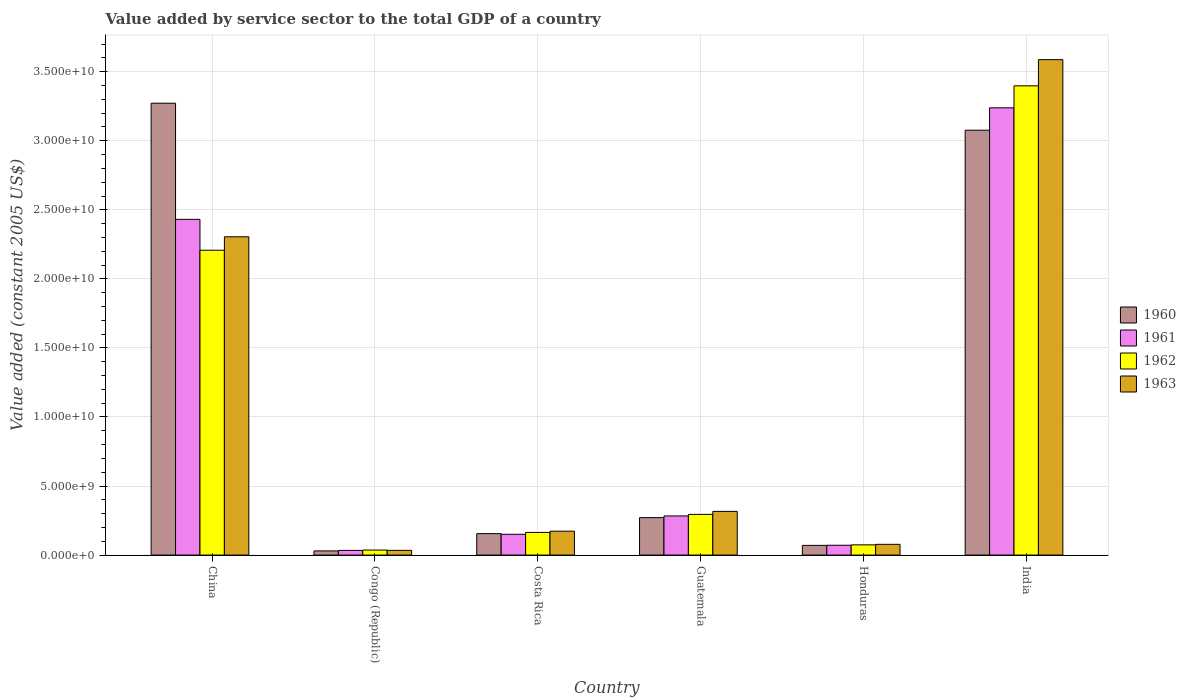How many groups of bars are there?
Your answer should be very brief. 6. Are the number of bars per tick equal to the number of legend labels?
Ensure brevity in your answer.  Yes. Are the number of bars on each tick of the X-axis equal?
Your answer should be very brief. Yes. How many bars are there on the 6th tick from the left?
Your answer should be very brief. 4. What is the label of the 2nd group of bars from the left?
Your answer should be very brief. Congo (Republic). In how many cases, is the number of bars for a given country not equal to the number of legend labels?
Offer a terse response. 0. What is the value added by service sector in 1960 in Congo (Republic)?
Offer a terse response. 3.02e+08. Across all countries, what is the maximum value added by service sector in 1961?
Your response must be concise. 3.24e+1. Across all countries, what is the minimum value added by service sector in 1962?
Provide a short and direct response. 3.64e+08. In which country was the value added by service sector in 1960 maximum?
Give a very brief answer. China. In which country was the value added by service sector in 1961 minimum?
Offer a terse response. Congo (Republic). What is the total value added by service sector in 1963 in the graph?
Keep it short and to the point. 6.49e+1. What is the difference between the value added by service sector in 1960 in China and that in Honduras?
Ensure brevity in your answer.  3.20e+1. What is the difference between the value added by service sector in 1961 in India and the value added by service sector in 1962 in Congo (Republic)?
Your answer should be compact. 3.20e+1. What is the average value added by service sector in 1963 per country?
Provide a short and direct response. 1.08e+1. What is the difference between the value added by service sector of/in 1961 and value added by service sector of/in 1963 in Congo (Republic)?
Your answer should be compact. -3.09e+06. What is the ratio of the value added by service sector in 1960 in China to that in Honduras?
Your answer should be very brief. 46.67. Is the difference between the value added by service sector in 1961 in Congo (Republic) and Guatemala greater than the difference between the value added by service sector in 1963 in Congo (Republic) and Guatemala?
Offer a terse response. Yes. What is the difference between the highest and the second highest value added by service sector in 1962?
Offer a very short reply. -1.91e+1. What is the difference between the highest and the lowest value added by service sector in 1961?
Your answer should be very brief. 3.21e+1. What does the 3rd bar from the left in India represents?
Offer a terse response. 1962. What does the 4th bar from the right in Guatemala represents?
Your answer should be compact. 1960. Are all the bars in the graph horizontal?
Give a very brief answer. No. How many countries are there in the graph?
Provide a succinct answer. 6. Does the graph contain any zero values?
Offer a very short reply. No. Where does the legend appear in the graph?
Your answer should be compact. Center right. How many legend labels are there?
Your answer should be compact. 4. What is the title of the graph?
Ensure brevity in your answer.  Value added by service sector to the total GDP of a country. What is the label or title of the X-axis?
Offer a terse response. Country. What is the label or title of the Y-axis?
Your answer should be compact. Value added (constant 2005 US$). What is the Value added (constant 2005 US$) in 1960 in China?
Your answer should be compact. 3.27e+1. What is the Value added (constant 2005 US$) of 1961 in China?
Ensure brevity in your answer.  2.43e+1. What is the Value added (constant 2005 US$) of 1962 in China?
Give a very brief answer. 2.21e+1. What is the Value added (constant 2005 US$) of 1963 in China?
Your response must be concise. 2.30e+1. What is the Value added (constant 2005 US$) of 1960 in Congo (Republic)?
Your answer should be very brief. 3.02e+08. What is the Value added (constant 2005 US$) in 1961 in Congo (Republic)?
Your answer should be very brief. 3.39e+08. What is the Value added (constant 2005 US$) in 1962 in Congo (Republic)?
Make the answer very short. 3.64e+08. What is the Value added (constant 2005 US$) of 1963 in Congo (Republic)?
Your response must be concise. 3.42e+08. What is the Value added (constant 2005 US$) of 1960 in Costa Rica?
Give a very brief answer. 1.55e+09. What is the Value added (constant 2005 US$) of 1961 in Costa Rica?
Your answer should be compact. 1.51e+09. What is the Value added (constant 2005 US$) in 1962 in Costa Rica?
Offer a terse response. 1.64e+09. What is the Value added (constant 2005 US$) in 1963 in Costa Rica?
Ensure brevity in your answer.  1.73e+09. What is the Value added (constant 2005 US$) of 1960 in Guatemala?
Ensure brevity in your answer.  2.71e+09. What is the Value added (constant 2005 US$) in 1961 in Guatemala?
Offer a very short reply. 2.83e+09. What is the Value added (constant 2005 US$) of 1962 in Guatemala?
Offer a terse response. 2.95e+09. What is the Value added (constant 2005 US$) in 1963 in Guatemala?
Your response must be concise. 3.16e+09. What is the Value added (constant 2005 US$) in 1960 in Honduras?
Keep it short and to the point. 7.01e+08. What is the Value added (constant 2005 US$) in 1961 in Honduras?
Make the answer very short. 7.12e+08. What is the Value added (constant 2005 US$) of 1962 in Honduras?
Offer a very short reply. 7.41e+08. What is the Value added (constant 2005 US$) in 1963 in Honduras?
Provide a succinct answer. 7.78e+08. What is the Value added (constant 2005 US$) of 1960 in India?
Give a very brief answer. 3.08e+1. What is the Value added (constant 2005 US$) of 1961 in India?
Ensure brevity in your answer.  3.24e+1. What is the Value added (constant 2005 US$) of 1962 in India?
Provide a succinct answer. 3.40e+1. What is the Value added (constant 2005 US$) in 1963 in India?
Give a very brief answer. 3.59e+1. Across all countries, what is the maximum Value added (constant 2005 US$) in 1960?
Provide a short and direct response. 3.27e+1. Across all countries, what is the maximum Value added (constant 2005 US$) of 1961?
Ensure brevity in your answer.  3.24e+1. Across all countries, what is the maximum Value added (constant 2005 US$) of 1962?
Make the answer very short. 3.40e+1. Across all countries, what is the maximum Value added (constant 2005 US$) in 1963?
Your response must be concise. 3.59e+1. Across all countries, what is the minimum Value added (constant 2005 US$) of 1960?
Provide a succinct answer. 3.02e+08. Across all countries, what is the minimum Value added (constant 2005 US$) of 1961?
Offer a very short reply. 3.39e+08. Across all countries, what is the minimum Value added (constant 2005 US$) in 1962?
Give a very brief answer. 3.64e+08. Across all countries, what is the minimum Value added (constant 2005 US$) in 1963?
Ensure brevity in your answer.  3.42e+08. What is the total Value added (constant 2005 US$) of 1960 in the graph?
Offer a very short reply. 6.88e+1. What is the total Value added (constant 2005 US$) in 1961 in the graph?
Keep it short and to the point. 6.21e+1. What is the total Value added (constant 2005 US$) of 1962 in the graph?
Your response must be concise. 6.18e+1. What is the total Value added (constant 2005 US$) in 1963 in the graph?
Give a very brief answer. 6.49e+1. What is the difference between the Value added (constant 2005 US$) in 1960 in China and that in Congo (Republic)?
Ensure brevity in your answer.  3.24e+1. What is the difference between the Value added (constant 2005 US$) of 1961 in China and that in Congo (Republic)?
Ensure brevity in your answer.  2.40e+1. What is the difference between the Value added (constant 2005 US$) in 1962 in China and that in Congo (Republic)?
Give a very brief answer. 2.17e+1. What is the difference between the Value added (constant 2005 US$) of 1963 in China and that in Congo (Republic)?
Offer a terse response. 2.27e+1. What is the difference between the Value added (constant 2005 US$) of 1960 in China and that in Costa Rica?
Your response must be concise. 3.12e+1. What is the difference between the Value added (constant 2005 US$) of 1961 in China and that in Costa Rica?
Your response must be concise. 2.28e+1. What is the difference between the Value added (constant 2005 US$) in 1962 in China and that in Costa Rica?
Give a very brief answer. 2.04e+1. What is the difference between the Value added (constant 2005 US$) in 1963 in China and that in Costa Rica?
Give a very brief answer. 2.13e+1. What is the difference between the Value added (constant 2005 US$) of 1960 in China and that in Guatemala?
Make the answer very short. 3.00e+1. What is the difference between the Value added (constant 2005 US$) of 1961 in China and that in Guatemala?
Your answer should be very brief. 2.15e+1. What is the difference between the Value added (constant 2005 US$) in 1962 in China and that in Guatemala?
Your response must be concise. 1.91e+1. What is the difference between the Value added (constant 2005 US$) in 1963 in China and that in Guatemala?
Your answer should be compact. 1.99e+1. What is the difference between the Value added (constant 2005 US$) of 1960 in China and that in Honduras?
Your response must be concise. 3.20e+1. What is the difference between the Value added (constant 2005 US$) of 1961 in China and that in Honduras?
Your answer should be compact. 2.36e+1. What is the difference between the Value added (constant 2005 US$) of 1962 in China and that in Honduras?
Give a very brief answer. 2.13e+1. What is the difference between the Value added (constant 2005 US$) of 1963 in China and that in Honduras?
Your answer should be very brief. 2.23e+1. What is the difference between the Value added (constant 2005 US$) in 1960 in China and that in India?
Make the answer very short. 1.95e+09. What is the difference between the Value added (constant 2005 US$) in 1961 in China and that in India?
Provide a short and direct response. -8.08e+09. What is the difference between the Value added (constant 2005 US$) of 1962 in China and that in India?
Keep it short and to the point. -1.19e+1. What is the difference between the Value added (constant 2005 US$) in 1963 in China and that in India?
Provide a short and direct response. -1.28e+1. What is the difference between the Value added (constant 2005 US$) in 1960 in Congo (Republic) and that in Costa Rica?
Keep it short and to the point. -1.25e+09. What is the difference between the Value added (constant 2005 US$) of 1961 in Congo (Republic) and that in Costa Rica?
Offer a terse response. -1.17e+09. What is the difference between the Value added (constant 2005 US$) in 1962 in Congo (Republic) and that in Costa Rica?
Provide a succinct answer. -1.28e+09. What is the difference between the Value added (constant 2005 US$) in 1963 in Congo (Republic) and that in Costa Rica?
Your response must be concise. -1.39e+09. What is the difference between the Value added (constant 2005 US$) of 1960 in Congo (Republic) and that in Guatemala?
Give a very brief answer. -2.41e+09. What is the difference between the Value added (constant 2005 US$) of 1961 in Congo (Republic) and that in Guatemala?
Keep it short and to the point. -2.49e+09. What is the difference between the Value added (constant 2005 US$) of 1962 in Congo (Republic) and that in Guatemala?
Provide a short and direct response. -2.58e+09. What is the difference between the Value added (constant 2005 US$) of 1963 in Congo (Republic) and that in Guatemala?
Your answer should be compact. -2.82e+09. What is the difference between the Value added (constant 2005 US$) in 1960 in Congo (Republic) and that in Honduras?
Keep it short and to the point. -4.00e+08. What is the difference between the Value added (constant 2005 US$) of 1961 in Congo (Republic) and that in Honduras?
Provide a short and direct response. -3.73e+08. What is the difference between the Value added (constant 2005 US$) of 1962 in Congo (Republic) and that in Honduras?
Offer a terse response. -3.77e+08. What is the difference between the Value added (constant 2005 US$) in 1963 in Congo (Republic) and that in Honduras?
Offer a very short reply. -4.36e+08. What is the difference between the Value added (constant 2005 US$) in 1960 in Congo (Republic) and that in India?
Offer a terse response. -3.05e+1. What is the difference between the Value added (constant 2005 US$) in 1961 in Congo (Republic) and that in India?
Make the answer very short. -3.21e+1. What is the difference between the Value added (constant 2005 US$) of 1962 in Congo (Republic) and that in India?
Offer a very short reply. -3.36e+1. What is the difference between the Value added (constant 2005 US$) of 1963 in Congo (Republic) and that in India?
Offer a very short reply. -3.55e+1. What is the difference between the Value added (constant 2005 US$) of 1960 in Costa Rica and that in Guatemala?
Offer a very short reply. -1.16e+09. What is the difference between the Value added (constant 2005 US$) of 1961 in Costa Rica and that in Guatemala?
Your answer should be compact. -1.33e+09. What is the difference between the Value added (constant 2005 US$) in 1962 in Costa Rica and that in Guatemala?
Your answer should be very brief. -1.31e+09. What is the difference between the Value added (constant 2005 US$) of 1963 in Costa Rica and that in Guatemala?
Your response must be concise. -1.43e+09. What is the difference between the Value added (constant 2005 US$) of 1960 in Costa Rica and that in Honduras?
Your response must be concise. 8.51e+08. What is the difference between the Value added (constant 2005 US$) of 1961 in Costa Rica and that in Honduras?
Ensure brevity in your answer.  7.94e+08. What is the difference between the Value added (constant 2005 US$) of 1962 in Costa Rica and that in Honduras?
Ensure brevity in your answer.  9.01e+08. What is the difference between the Value added (constant 2005 US$) of 1963 in Costa Rica and that in Honduras?
Make the answer very short. 9.53e+08. What is the difference between the Value added (constant 2005 US$) in 1960 in Costa Rica and that in India?
Your answer should be compact. -2.92e+1. What is the difference between the Value added (constant 2005 US$) of 1961 in Costa Rica and that in India?
Ensure brevity in your answer.  -3.09e+1. What is the difference between the Value added (constant 2005 US$) in 1962 in Costa Rica and that in India?
Give a very brief answer. -3.23e+1. What is the difference between the Value added (constant 2005 US$) of 1963 in Costa Rica and that in India?
Offer a terse response. -3.41e+1. What is the difference between the Value added (constant 2005 US$) of 1960 in Guatemala and that in Honduras?
Offer a terse response. 2.01e+09. What is the difference between the Value added (constant 2005 US$) in 1961 in Guatemala and that in Honduras?
Make the answer very short. 2.12e+09. What is the difference between the Value added (constant 2005 US$) of 1962 in Guatemala and that in Honduras?
Your answer should be compact. 2.21e+09. What is the difference between the Value added (constant 2005 US$) of 1963 in Guatemala and that in Honduras?
Offer a terse response. 2.39e+09. What is the difference between the Value added (constant 2005 US$) in 1960 in Guatemala and that in India?
Your answer should be compact. -2.81e+1. What is the difference between the Value added (constant 2005 US$) of 1961 in Guatemala and that in India?
Offer a very short reply. -2.96e+1. What is the difference between the Value added (constant 2005 US$) in 1962 in Guatemala and that in India?
Offer a terse response. -3.10e+1. What is the difference between the Value added (constant 2005 US$) of 1963 in Guatemala and that in India?
Make the answer very short. -3.27e+1. What is the difference between the Value added (constant 2005 US$) of 1960 in Honduras and that in India?
Offer a terse response. -3.01e+1. What is the difference between the Value added (constant 2005 US$) in 1961 in Honduras and that in India?
Your response must be concise. -3.17e+1. What is the difference between the Value added (constant 2005 US$) of 1962 in Honduras and that in India?
Ensure brevity in your answer.  -3.32e+1. What is the difference between the Value added (constant 2005 US$) of 1963 in Honduras and that in India?
Provide a succinct answer. -3.51e+1. What is the difference between the Value added (constant 2005 US$) of 1960 in China and the Value added (constant 2005 US$) of 1961 in Congo (Republic)?
Give a very brief answer. 3.24e+1. What is the difference between the Value added (constant 2005 US$) in 1960 in China and the Value added (constant 2005 US$) in 1962 in Congo (Republic)?
Provide a short and direct response. 3.24e+1. What is the difference between the Value added (constant 2005 US$) in 1960 in China and the Value added (constant 2005 US$) in 1963 in Congo (Republic)?
Ensure brevity in your answer.  3.24e+1. What is the difference between the Value added (constant 2005 US$) of 1961 in China and the Value added (constant 2005 US$) of 1962 in Congo (Republic)?
Make the answer very short. 2.39e+1. What is the difference between the Value added (constant 2005 US$) of 1961 in China and the Value added (constant 2005 US$) of 1963 in Congo (Republic)?
Make the answer very short. 2.40e+1. What is the difference between the Value added (constant 2005 US$) in 1962 in China and the Value added (constant 2005 US$) in 1963 in Congo (Republic)?
Provide a short and direct response. 2.17e+1. What is the difference between the Value added (constant 2005 US$) in 1960 in China and the Value added (constant 2005 US$) in 1961 in Costa Rica?
Ensure brevity in your answer.  3.12e+1. What is the difference between the Value added (constant 2005 US$) in 1960 in China and the Value added (constant 2005 US$) in 1962 in Costa Rica?
Your answer should be compact. 3.11e+1. What is the difference between the Value added (constant 2005 US$) in 1960 in China and the Value added (constant 2005 US$) in 1963 in Costa Rica?
Your response must be concise. 3.10e+1. What is the difference between the Value added (constant 2005 US$) in 1961 in China and the Value added (constant 2005 US$) in 1962 in Costa Rica?
Your response must be concise. 2.27e+1. What is the difference between the Value added (constant 2005 US$) in 1961 in China and the Value added (constant 2005 US$) in 1963 in Costa Rica?
Give a very brief answer. 2.26e+1. What is the difference between the Value added (constant 2005 US$) in 1962 in China and the Value added (constant 2005 US$) in 1963 in Costa Rica?
Keep it short and to the point. 2.03e+1. What is the difference between the Value added (constant 2005 US$) of 1960 in China and the Value added (constant 2005 US$) of 1961 in Guatemala?
Your answer should be compact. 2.99e+1. What is the difference between the Value added (constant 2005 US$) in 1960 in China and the Value added (constant 2005 US$) in 1962 in Guatemala?
Provide a succinct answer. 2.98e+1. What is the difference between the Value added (constant 2005 US$) in 1960 in China and the Value added (constant 2005 US$) in 1963 in Guatemala?
Provide a succinct answer. 2.96e+1. What is the difference between the Value added (constant 2005 US$) in 1961 in China and the Value added (constant 2005 US$) in 1962 in Guatemala?
Ensure brevity in your answer.  2.14e+1. What is the difference between the Value added (constant 2005 US$) in 1961 in China and the Value added (constant 2005 US$) in 1963 in Guatemala?
Give a very brief answer. 2.11e+1. What is the difference between the Value added (constant 2005 US$) of 1962 in China and the Value added (constant 2005 US$) of 1963 in Guatemala?
Keep it short and to the point. 1.89e+1. What is the difference between the Value added (constant 2005 US$) of 1960 in China and the Value added (constant 2005 US$) of 1961 in Honduras?
Keep it short and to the point. 3.20e+1. What is the difference between the Value added (constant 2005 US$) of 1960 in China and the Value added (constant 2005 US$) of 1962 in Honduras?
Ensure brevity in your answer.  3.20e+1. What is the difference between the Value added (constant 2005 US$) in 1960 in China and the Value added (constant 2005 US$) in 1963 in Honduras?
Your answer should be very brief. 3.19e+1. What is the difference between the Value added (constant 2005 US$) of 1961 in China and the Value added (constant 2005 US$) of 1962 in Honduras?
Offer a very short reply. 2.36e+1. What is the difference between the Value added (constant 2005 US$) in 1961 in China and the Value added (constant 2005 US$) in 1963 in Honduras?
Make the answer very short. 2.35e+1. What is the difference between the Value added (constant 2005 US$) in 1962 in China and the Value added (constant 2005 US$) in 1963 in Honduras?
Make the answer very short. 2.13e+1. What is the difference between the Value added (constant 2005 US$) in 1960 in China and the Value added (constant 2005 US$) in 1961 in India?
Your answer should be compact. 3.34e+08. What is the difference between the Value added (constant 2005 US$) of 1960 in China and the Value added (constant 2005 US$) of 1962 in India?
Offer a very short reply. -1.26e+09. What is the difference between the Value added (constant 2005 US$) of 1960 in China and the Value added (constant 2005 US$) of 1963 in India?
Provide a short and direct response. -3.15e+09. What is the difference between the Value added (constant 2005 US$) of 1961 in China and the Value added (constant 2005 US$) of 1962 in India?
Provide a succinct answer. -9.67e+09. What is the difference between the Value added (constant 2005 US$) of 1961 in China and the Value added (constant 2005 US$) of 1963 in India?
Your response must be concise. -1.16e+1. What is the difference between the Value added (constant 2005 US$) of 1962 in China and the Value added (constant 2005 US$) of 1963 in India?
Make the answer very short. -1.38e+1. What is the difference between the Value added (constant 2005 US$) of 1960 in Congo (Republic) and the Value added (constant 2005 US$) of 1961 in Costa Rica?
Ensure brevity in your answer.  -1.20e+09. What is the difference between the Value added (constant 2005 US$) in 1960 in Congo (Republic) and the Value added (constant 2005 US$) in 1962 in Costa Rica?
Make the answer very short. -1.34e+09. What is the difference between the Value added (constant 2005 US$) in 1960 in Congo (Republic) and the Value added (constant 2005 US$) in 1963 in Costa Rica?
Your response must be concise. -1.43e+09. What is the difference between the Value added (constant 2005 US$) in 1961 in Congo (Republic) and the Value added (constant 2005 US$) in 1962 in Costa Rica?
Provide a succinct answer. -1.30e+09. What is the difference between the Value added (constant 2005 US$) in 1961 in Congo (Republic) and the Value added (constant 2005 US$) in 1963 in Costa Rica?
Offer a very short reply. -1.39e+09. What is the difference between the Value added (constant 2005 US$) in 1962 in Congo (Republic) and the Value added (constant 2005 US$) in 1963 in Costa Rica?
Give a very brief answer. -1.37e+09. What is the difference between the Value added (constant 2005 US$) of 1960 in Congo (Republic) and the Value added (constant 2005 US$) of 1961 in Guatemala?
Offer a very short reply. -2.53e+09. What is the difference between the Value added (constant 2005 US$) of 1960 in Congo (Republic) and the Value added (constant 2005 US$) of 1962 in Guatemala?
Offer a terse response. -2.65e+09. What is the difference between the Value added (constant 2005 US$) in 1960 in Congo (Republic) and the Value added (constant 2005 US$) in 1963 in Guatemala?
Your answer should be compact. -2.86e+09. What is the difference between the Value added (constant 2005 US$) of 1961 in Congo (Republic) and the Value added (constant 2005 US$) of 1962 in Guatemala?
Your answer should be very brief. -2.61e+09. What is the difference between the Value added (constant 2005 US$) in 1961 in Congo (Republic) and the Value added (constant 2005 US$) in 1963 in Guatemala?
Provide a short and direct response. -2.83e+09. What is the difference between the Value added (constant 2005 US$) of 1962 in Congo (Republic) and the Value added (constant 2005 US$) of 1963 in Guatemala?
Your response must be concise. -2.80e+09. What is the difference between the Value added (constant 2005 US$) in 1960 in Congo (Republic) and the Value added (constant 2005 US$) in 1961 in Honduras?
Your answer should be compact. -4.10e+08. What is the difference between the Value added (constant 2005 US$) of 1960 in Congo (Republic) and the Value added (constant 2005 US$) of 1962 in Honduras?
Offer a terse response. -4.39e+08. What is the difference between the Value added (constant 2005 US$) in 1960 in Congo (Republic) and the Value added (constant 2005 US$) in 1963 in Honduras?
Provide a succinct answer. -4.76e+08. What is the difference between the Value added (constant 2005 US$) in 1961 in Congo (Republic) and the Value added (constant 2005 US$) in 1962 in Honduras?
Your answer should be very brief. -4.02e+08. What is the difference between the Value added (constant 2005 US$) in 1961 in Congo (Republic) and the Value added (constant 2005 US$) in 1963 in Honduras?
Keep it short and to the point. -4.39e+08. What is the difference between the Value added (constant 2005 US$) of 1962 in Congo (Republic) and the Value added (constant 2005 US$) of 1963 in Honduras?
Your response must be concise. -4.14e+08. What is the difference between the Value added (constant 2005 US$) in 1960 in Congo (Republic) and the Value added (constant 2005 US$) in 1961 in India?
Offer a terse response. -3.21e+1. What is the difference between the Value added (constant 2005 US$) in 1960 in Congo (Republic) and the Value added (constant 2005 US$) in 1962 in India?
Your answer should be compact. -3.37e+1. What is the difference between the Value added (constant 2005 US$) of 1960 in Congo (Republic) and the Value added (constant 2005 US$) of 1963 in India?
Provide a succinct answer. -3.56e+1. What is the difference between the Value added (constant 2005 US$) of 1961 in Congo (Republic) and the Value added (constant 2005 US$) of 1962 in India?
Provide a succinct answer. -3.36e+1. What is the difference between the Value added (constant 2005 US$) in 1961 in Congo (Republic) and the Value added (constant 2005 US$) in 1963 in India?
Make the answer very short. -3.55e+1. What is the difference between the Value added (constant 2005 US$) in 1962 in Congo (Republic) and the Value added (constant 2005 US$) in 1963 in India?
Your response must be concise. -3.55e+1. What is the difference between the Value added (constant 2005 US$) in 1960 in Costa Rica and the Value added (constant 2005 US$) in 1961 in Guatemala?
Make the answer very short. -1.28e+09. What is the difference between the Value added (constant 2005 US$) of 1960 in Costa Rica and the Value added (constant 2005 US$) of 1962 in Guatemala?
Ensure brevity in your answer.  -1.39e+09. What is the difference between the Value added (constant 2005 US$) of 1960 in Costa Rica and the Value added (constant 2005 US$) of 1963 in Guatemala?
Provide a short and direct response. -1.61e+09. What is the difference between the Value added (constant 2005 US$) in 1961 in Costa Rica and the Value added (constant 2005 US$) in 1962 in Guatemala?
Your answer should be compact. -1.44e+09. What is the difference between the Value added (constant 2005 US$) in 1961 in Costa Rica and the Value added (constant 2005 US$) in 1963 in Guatemala?
Provide a succinct answer. -1.66e+09. What is the difference between the Value added (constant 2005 US$) in 1962 in Costa Rica and the Value added (constant 2005 US$) in 1963 in Guatemala?
Ensure brevity in your answer.  -1.52e+09. What is the difference between the Value added (constant 2005 US$) of 1960 in Costa Rica and the Value added (constant 2005 US$) of 1961 in Honduras?
Offer a terse response. 8.41e+08. What is the difference between the Value added (constant 2005 US$) in 1960 in Costa Rica and the Value added (constant 2005 US$) in 1962 in Honduras?
Provide a short and direct response. 8.12e+08. What is the difference between the Value added (constant 2005 US$) of 1960 in Costa Rica and the Value added (constant 2005 US$) of 1963 in Honduras?
Offer a terse response. 7.75e+08. What is the difference between the Value added (constant 2005 US$) of 1961 in Costa Rica and the Value added (constant 2005 US$) of 1962 in Honduras?
Your answer should be very brief. 7.65e+08. What is the difference between the Value added (constant 2005 US$) of 1961 in Costa Rica and the Value added (constant 2005 US$) of 1963 in Honduras?
Your answer should be very brief. 7.28e+08. What is the difference between the Value added (constant 2005 US$) of 1962 in Costa Rica and the Value added (constant 2005 US$) of 1963 in Honduras?
Your answer should be very brief. 8.63e+08. What is the difference between the Value added (constant 2005 US$) in 1960 in Costa Rica and the Value added (constant 2005 US$) in 1961 in India?
Offer a very short reply. -3.08e+1. What is the difference between the Value added (constant 2005 US$) in 1960 in Costa Rica and the Value added (constant 2005 US$) in 1962 in India?
Provide a short and direct response. -3.24e+1. What is the difference between the Value added (constant 2005 US$) of 1960 in Costa Rica and the Value added (constant 2005 US$) of 1963 in India?
Your answer should be very brief. -3.43e+1. What is the difference between the Value added (constant 2005 US$) in 1961 in Costa Rica and the Value added (constant 2005 US$) in 1962 in India?
Keep it short and to the point. -3.25e+1. What is the difference between the Value added (constant 2005 US$) in 1961 in Costa Rica and the Value added (constant 2005 US$) in 1963 in India?
Offer a terse response. -3.44e+1. What is the difference between the Value added (constant 2005 US$) of 1962 in Costa Rica and the Value added (constant 2005 US$) of 1963 in India?
Keep it short and to the point. -3.42e+1. What is the difference between the Value added (constant 2005 US$) in 1960 in Guatemala and the Value added (constant 2005 US$) in 1961 in Honduras?
Offer a terse response. 2.00e+09. What is the difference between the Value added (constant 2005 US$) in 1960 in Guatemala and the Value added (constant 2005 US$) in 1962 in Honduras?
Your response must be concise. 1.97e+09. What is the difference between the Value added (constant 2005 US$) in 1960 in Guatemala and the Value added (constant 2005 US$) in 1963 in Honduras?
Your answer should be compact. 1.93e+09. What is the difference between the Value added (constant 2005 US$) of 1961 in Guatemala and the Value added (constant 2005 US$) of 1962 in Honduras?
Offer a terse response. 2.09e+09. What is the difference between the Value added (constant 2005 US$) of 1961 in Guatemala and the Value added (constant 2005 US$) of 1963 in Honduras?
Your answer should be very brief. 2.06e+09. What is the difference between the Value added (constant 2005 US$) in 1962 in Guatemala and the Value added (constant 2005 US$) in 1963 in Honduras?
Give a very brief answer. 2.17e+09. What is the difference between the Value added (constant 2005 US$) of 1960 in Guatemala and the Value added (constant 2005 US$) of 1961 in India?
Offer a very short reply. -2.97e+1. What is the difference between the Value added (constant 2005 US$) in 1960 in Guatemala and the Value added (constant 2005 US$) in 1962 in India?
Keep it short and to the point. -3.13e+1. What is the difference between the Value added (constant 2005 US$) in 1960 in Guatemala and the Value added (constant 2005 US$) in 1963 in India?
Offer a very short reply. -3.32e+1. What is the difference between the Value added (constant 2005 US$) in 1961 in Guatemala and the Value added (constant 2005 US$) in 1962 in India?
Give a very brief answer. -3.11e+1. What is the difference between the Value added (constant 2005 US$) in 1961 in Guatemala and the Value added (constant 2005 US$) in 1963 in India?
Provide a succinct answer. -3.30e+1. What is the difference between the Value added (constant 2005 US$) of 1962 in Guatemala and the Value added (constant 2005 US$) of 1963 in India?
Keep it short and to the point. -3.29e+1. What is the difference between the Value added (constant 2005 US$) in 1960 in Honduras and the Value added (constant 2005 US$) in 1961 in India?
Your answer should be compact. -3.17e+1. What is the difference between the Value added (constant 2005 US$) of 1960 in Honduras and the Value added (constant 2005 US$) of 1962 in India?
Make the answer very short. -3.33e+1. What is the difference between the Value added (constant 2005 US$) of 1960 in Honduras and the Value added (constant 2005 US$) of 1963 in India?
Your response must be concise. -3.52e+1. What is the difference between the Value added (constant 2005 US$) of 1961 in Honduras and the Value added (constant 2005 US$) of 1962 in India?
Ensure brevity in your answer.  -3.33e+1. What is the difference between the Value added (constant 2005 US$) of 1961 in Honduras and the Value added (constant 2005 US$) of 1963 in India?
Provide a short and direct response. -3.52e+1. What is the difference between the Value added (constant 2005 US$) of 1962 in Honduras and the Value added (constant 2005 US$) of 1963 in India?
Give a very brief answer. -3.51e+1. What is the average Value added (constant 2005 US$) in 1960 per country?
Offer a very short reply. 1.15e+1. What is the average Value added (constant 2005 US$) in 1961 per country?
Your answer should be compact. 1.03e+1. What is the average Value added (constant 2005 US$) in 1962 per country?
Keep it short and to the point. 1.03e+1. What is the average Value added (constant 2005 US$) of 1963 per country?
Keep it short and to the point. 1.08e+1. What is the difference between the Value added (constant 2005 US$) of 1960 and Value added (constant 2005 US$) of 1961 in China?
Your response must be concise. 8.41e+09. What is the difference between the Value added (constant 2005 US$) of 1960 and Value added (constant 2005 US$) of 1962 in China?
Your answer should be compact. 1.06e+1. What is the difference between the Value added (constant 2005 US$) in 1960 and Value added (constant 2005 US$) in 1963 in China?
Ensure brevity in your answer.  9.68e+09. What is the difference between the Value added (constant 2005 US$) of 1961 and Value added (constant 2005 US$) of 1962 in China?
Your answer should be compact. 2.24e+09. What is the difference between the Value added (constant 2005 US$) in 1961 and Value added (constant 2005 US$) in 1963 in China?
Provide a succinct answer. 1.27e+09. What is the difference between the Value added (constant 2005 US$) in 1962 and Value added (constant 2005 US$) in 1963 in China?
Your answer should be compact. -9.71e+08. What is the difference between the Value added (constant 2005 US$) of 1960 and Value added (constant 2005 US$) of 1961 in Congo (Republic)?
Your answer should be compact. -3.74e+07. What is the difference between the Value added (constant 2005 US$) in 1960 and Value added (constant 2005 US$) in 1962 in Congo (Republic)?
Make the answer very short. -6.23e+07. What is the difference between the Value added (constant 2005 US$) of 1960 and Value added (constant 2005 US$) of 1963 in Congo (Republic)?
Provide a short and direct response. -4.05e+07. What is the difference between the Value added (constant 2005 US$) of 1961 and Value added (constant 2005 US$) of 1962 in Congo (Republic)?
Your answer should be very brief. -2.49e+07. What is the difference between the Value added (constant 2005 US$) in 1961 and Value added (constant 2005 US$) in 1963 in Congo (Republic)?
Provide a short and direct response. -3.09e+06. What is the difference between the Value added (constant 2005 US$) of 1962 and Value added (constant 2005 US$) of 1963 in Congo (Republic)?
Your response must be concise. 2.18e+07. What is the difference between the Value added (constant 2005 US$) in 1960 and Value added (constant 2005 US$) in 1961 in Costa Rica?
Provide a short and direct response. 4.72e+07. What is the difference between the Value added (constant 2005 US$) in 1960 and Value added (constant 2005 US$) in 1962 in Costa Rica?
Keep it short and to the point. -8.87e+07. What is the difference between the Value added (constant 2005 US$) of 1960 and Value added (constant 2005 US$) of 1963 in Costa Rica?
Provide a succinct answer. -1.78e+08. What is the difference between the Value added (constant 2005 US$) of 1961 and Value added (constant 2005 US$) of 1962 in Costa Rica?
Ensure brevity in your answer.  -1.36e+08. What is the difference between the Value added (constant 2005 US$) of 1961 and Value added (constant 2005 US$) of 1963 in Costa Rica?
Your response must be concise. -2.25e+08. What is the difference between the Value added (constant 2005 US$) of 1962 and Value added (constant 2005 US$) of 1963 in Costa Rica?
Make the answer very short. -8.94e+07. What is the difference between the Value added (constant 2005 US$) in 1960 and Value added (constant 2005 US$) in 1961 in Guatemala?
Your answer should be very brief. -1.22e+08. What is the difference between the Value added (constant 2005 US$) of 1960 and Value added (constant 2005 US$) of 1962 in Guatemala?
Your response must be concise. -2.35e+08. What is the difference between the Value added (constant 2005 US$) in 1960 and Value added (constant 2005 US$) in 1963 in Guatemala?
Offer a very short reply. -4.53e+08. What is the difference between the Value added (constant 2005 US$) of 1961 and Value added (constant 2005 US$) of 1962 in Guatemala?
Give a very brief answer. -1.14e+08. What is the difference between the Value added (constant 2005 US$) in 1961 and Value added (constant 2005 US$) in 1963 in Guatemala?
Offer a very short reply. -3.31e+08. What is the difference between the Value added (constant 2005 US$) in 1962 and Value added (constant 2005 US$) in 1963 in Guatemala?
Your answer should be compact. -2.17e+08. What is the difference between the Value added (constant 2005 US$) in 1960 and Value added (constant 2005 US$) in 1961 in Honduras?
Provide a short and direct response. -1.04e+07. What is the difference between the Value added (constant 2005 US$) in 1960 and Value added (constant 2005 US$) in 1962 in Honduras?
Provide a short and direct response. -3.93e+07. What is the difference between the Value added (constant 2005 US$) in 1960 and Value added (constant 2005 US$) in 1963 in Honduras?
Provide a succinct answer. -7.65e+07. What is the difference between the Value added (constant 2005 US$) of 1961 and Value added (constant 2005 US$) of 1962 in Honduras?
Offer a terse response. -2.89e+07. What is the difference between the Value added (constant 2005 US$) of 1961 and Value added (constant 2005 US$) of 1963 in Honduras?
Ensure brevity in your answer.  -6.62e+07. What is the difference between the Value added (constant 2005 US$) in 1962 and Value added (constant 2005 US$) in 1963 in Honduras?
Provide a short and direct response. -3.72e+07. What is the difference between the Value added (constant 2005 US$) in 1960 and Value added (constant 2005 US$) in 1961 in India?
Keep it short and to the point. -1.62e+09. What is the difference between the Value added (constant 2005 US$) of 1960 and Value added (constant 2005 US$) of 1962 in India?
Your answer should be compact. -3.21e+09. What is the difference between the Value added (constant 2005 US$) in 1960 and Value added (constant 2005 US$) in 1963 in India?
Your response must be concise. -5.11e+09. What is the difference between the Value added (constant 2005 US$) of 1961 and Value added (constant 2005 US$) of 1962 in India?
Give a very brief answer. -1.59e+09. What is the difference between the Value added (constant 2005 US$) in 1961 and Value added (constant 2005 US$) in 1963 in India?
Give a very brief answer. -3.49e+09. What is the difference between the Value added (constant 2005 US$) of 1962 and Value added (constant 2005 US$) of 1963 in India?
Provide a short and direct response. -1.90e+09. What is the ratio of the Value added (constant 2005 US$) of 1960 in China to that in Congo (Republic)?
Ensure brevity in your answer.  108.51. What is the ratio of the Value added (constant 2005 US$) in 1961 in China to that in Congo (Republic)?
Your answer should be compact. 71.73. What is the ratio of the Value added (constant 2005 US$) of 1962 in China to that in Congo (Republic)?
Give a very brief answer. 60.67. What is the ratio of the Value added (constant 2005 US$) of 1963 in China to that in Congo (Republic)?
Provide a short and direct response. 67.39. What is the ratio of the Value added (constant 2005 US$) in 1960 in China to that in Costa Rica?
Keep it short and to the point. 21.08. What is the ratio of the Value added (constant 2005 US$) of 1961 in China to that in Costa Rica?
Provide a short and direct response. 16.15. What is the ratio of the Value added (constant 2005 US$) of 1962 in China to that in Costa Rica?
Offer a very short reply. 13.45. What is the ratio of the Value added (constant 2005 US$) of 1963 in China to that in Costa Rica?
Keep it short and to the point. 13.32. What is the ratio of the Value added (constant 2005 US$) in 1960 in China to that in Guatemala?
Provide a short and direct response. 12.07. What is the ratio of the Value added (constant 2005 US$) in 1961 in China to that in Guatemala?
Keep it short and to the point. 8.58. What is the ratio of the Value added (constant 2005 US$) in 1962 in China to that in Guatemala?
Your answer should be very brief. 7.49. What is the ratio of the Value added (constant 2005 US$) of 1963 in China to that in Guatemala?
Give a very brief answer. 7.28. What is the ratio of the Value added (constant 2005 US$) of 1960 in China to that in Honduras?
Give a very brief answer. 46.67. What is the ratio of the Value added (constant 2005 US$) in 1961 in China to that in Honduras?
Your response must be concise. 34.17. What is the ratio of the Value added (constant 2005 US$) in 1962 in China to that in Honduras?
Your response must be concise. 29.81. What is the ratio of the Value added (constant 2005 US$) of 1963 in China to that in Honduras?
Offer a very short reply. 29.63. What is the ratio of the Value added (constant 2005 US$) in 1960 in China to that in India?
Offer a very short reply. 1.06. What is the ratio of the Value added (constant 2005 US$) in 1961 in China to that in India?
Offer a terse response. 0.75. What is the ratio of the Value added (constant 2005 US$) of 1962 in China to that in India?
Ensure brevity in your answer.  0.65. What is the ratio of the Value added (constant 2005 US$) in 1963 in China to that in India?
Your response must be concise. 0.64. What is the ratio of the Value added (constant 2005 US$) in 1960 in Congo (Republic) to that in Costa Rica?
Your answer should be compact. 0.19. What is the ratio of the Value added (constant 2005 US$) of 1961 in Congo (Republic) to that in Costa Rica?
Provide a succinct answer. 0.23. What is the ratio of the Value added (constant 2005 US$) of 1962 in Congo (Republic) to that in Costa Rica?
Your answer should be compact. 0.22. What is the ratio of the Value added (constant 2005 US$) of 1963 in Congo (Republic) to that in Costa Rica?
Ensure brevity in your answer.  0.2. What is the ratio of the Value added (constant 2005 US$) in 1960 in Congo (Republic) to that in Guatemala?
Provide a succinct answer. 0.11. What is the ratio of the Value added (constant 2005 US$) in 1961 in Congo (Republic) to that in Guatemala?
Keep it short and to the point. 0.12. What is the ratio of the Value added (constant 2005 US$) in 1962 in Congo (Republic) to that in Guatemala?
Provide a short and direct response. 0.12. What is the ratio of the Value added (constant 2005 US$) of 1963 in Congo (Republic) to that in Guatemala?
Keep it short and to the point. 0.11. What is the ratio of the Value added (constant 2005 US$) in 1960 in Congo (Republic) to that in Honduras?
Make the answer very short. 0.43. What is the ratio of the Value added (constant 2005 US$) in 1961 in Congo (Republic) to that in Honduras?
Your answer should be compact. 0.48. What is the ratio of the Value added (constant 2005 US$) in 1962 in Congo (Republic) to that in Honduras?
Your answer should be compact. 0.49. What is the ratio of the Value added (constant 2005 US$) of 1963 in Congo (Republic) to that in Honduras?
Your answer should be compact. 0.44. What is the ratio of the Value added (constant 2005 US$) of 1960 in Congo (Republic) to that in India?
Ensure brevity in your answer.  0.01. What is the ratio of the Value added (constant 2005 US$) in 1961 in Congo (Republic) to that in India?
Your answer should be compact. 0.01. What is the ratio of the Value added (constant 2005 US$) in 1962 in Congo (Republic) to that in India?
Keep it short and to the point. 0.01. What is the ratio of the Value added (constant 2005 US$) in 1963 in Congo (Republic) to that in India?
Your response must be concise. 0.01. What is the ratio of the Value added (constant 2005 US$) of 1960 in Costa Rica to that in Guatemala?
Make the answer very short. 0.57. What is the ratio of the Value added (constant 2005 US$) of 1961 in Costa Rica to that in Guatemala?
Provide a short and direct response. 0.53. What is the ratio of the Value added (constant 2005 US$) in 1962 in Costa Rica to that in Guatemala?
Offer a terse response. 0.56. What is the ratio of the Value added (constant 2005 US$) of 1963 in Costa Rica to that in Guatemala?
Your answer should be very brief. 0.55. What is the ratio of the Value added (constant 2005 US$) of 1960 in Costa Rica to that in Honduras?
Make the answer very short. 2.21. What is the ratio of the Value added (constant 2005 US$) in 1961 in Costa Rica to that in Honduras?
Offer a very short reply. 2.12. What is the ratio of the Value added (constant 2005 US$) in 1962 in Costa Rica to that in Honduras?
Your response must be concise. 2.22. What is the ratio of the Value added (constant 2005 US$) in 1963 in Costa Rica to that in Honduras?
Give a very brief answer. 2.23. What is the ratio of the Value added (constant 2005 US$) of 1960 in Costa Rica to that in India?
Provide a short and direct response. 0.05. What is the ratio of the Value added (constant 2005 US$) of 1961 in Costa Rica to that in India?
Offer a terse response. 0.05. What is the ratio of the Value added (constant 2005 US$) of 1962 in Costa Rica to that in India?
Offer a terse response. 0.05. What is the ratio of the Value added (constant 2005 US$) of 1963 in Costa Rica to that in India?
Offer a terse response. 0.05. What is the ratio of the Value added (constant 2005 US$) of 1960 in Guatemala to that in Honduras?
Offer a terse response. 3.87. What is the ratio of the Value added (constant 2005 US$) in 1961 in Guatemala to that in Honduras?
Provide a short and direct response. 3.98. What is the ratio of the Value added (constant 2005 US$) of 1962 in Guatemala to that in Honduras?
Ensure brevity in your answer.  3.98. What is the ratio of the Value added (constant 2005 US$) of 1963 in Guatemala to that in Honduras?
Your answer should be very brief. 4.07. What is the ratio of the Value added (constant 2005 US$) in 1960 in Guatemala to that in India?
Make the answer very short. 0.09. What is the ratio of the Value added (constant 2005 US$) in 1961 in Guatemala to that in India?
Provide a short and direct response. 0.09. What is the ratio of the Value added (constant 2005 US$) in 1962 in Guatemala to that in India?
Your answer should be compact. 0.09. What is the ratio of the Value added (constant 2005 US$) in 1963 in Guatemala to that in India?
Keep it short and to the point. 0.09. What is the ratio of the Value added (constant 2005 US$) in 1960 in Honduras to that in India?
Your answer should be very brief. 0.02. What is the ratio of the Value added (constant 2005 US$) of 1961 in Honduras to that in India?
Your answer should be compact. 0.02. What is the ratio of the Value added (constant 2005 US$) in 1962 in Honduras to that in India?
Your response must be concise. 0.02. What is the ratio of the Value added (constant 2005 US$) of 1963 in Honduras to that in India?
Provide a succinct answer. 0.02. What is the difference between the highest and the second highest Value added (constant 2005 US$) in 1960?
Your response must be concise. 1.95e+09. What is the difference between the highest and the second highest Value added (constant 2005 US$) of 1961?
Offer a very short reply. 8.08e+09. What is the difference between the highest and the second highest Value added (constant 2005 US$) in 1962?
Provide a short and direct response. 1.19e+1. What is the difference between the highest and the second highest Value added (constant 2005 US$) in 1963?
Make the answer very short. 1.28e+1. What is the difference between the highest and the lowest Value added (constant 2005 US$) of 1960?
Give a very brief answer. 3.24e+1. What is the difference between the highest and the lowest Value added (constant 2005 US$) in 1961?
Make the answer very short. 3.21e+1. What is the difference between the highest and the lowest Value added (constant 2005 US$) in 1962?
Your answer should be compact. 3.36e+1. What is the difference between the highest and the lowest Value added (constant 2005 US$) in 1963?
Ensure brevity in your answer.  3.55e+1. 